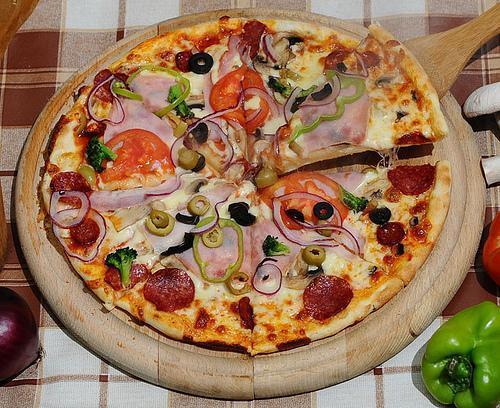How many pizzas are in this picture?
Give a very brief answer. 1. 